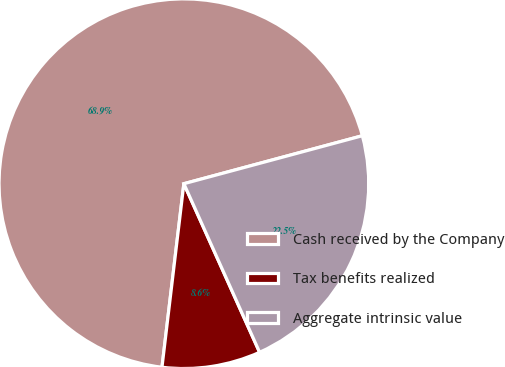Convert chart to OTSL. <chart><loc_0><loc_0><loc_500><loc_500><pie_chart><fcel>Cash received by the Company<fcel>Tax benefits realized<fcel>Aggregate intrinsic value<nl><fcel>68.93%<fcel>8.61%<fcel>22.46%<nl></chart> 